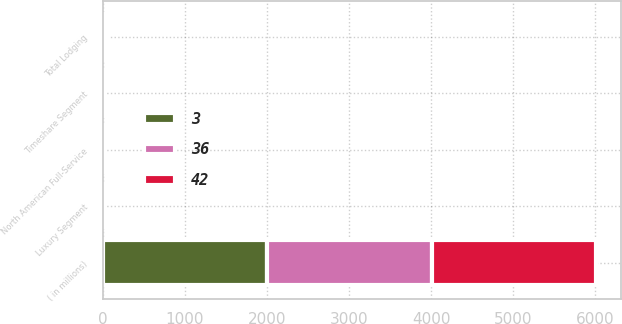Convert chart to OTSL. <chart><loc_0><loc_0><loc_500><loc_500><stacked_bar_chart><ecel><fcel>( in millions)<fcel>North American Full-Service<fcel>Luxury Segment<fcel>Timeshare Segment<fcel>Total Lodging<nl><fcel>36<fcel>2006<fcel>2<fcel>2<fcel>2<fcel>2<nl><fcel>3<fcel>2005<fcel>21<fcel>1<fcel>1<fcel>35<nl><fcel>42<fcel>2004<fcel>8<fcel>3<fcel>7<fcel>14<nl></chart> 